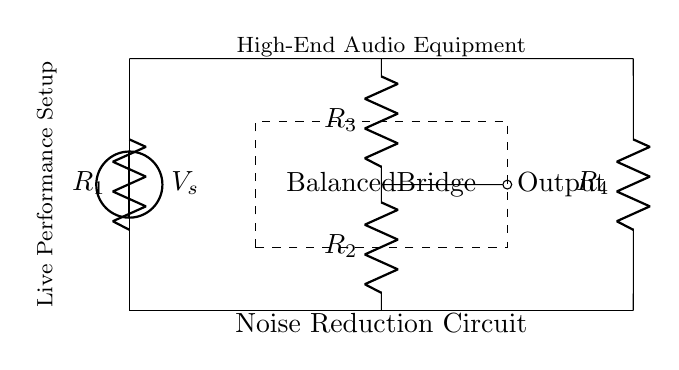What is the total number of resistors in the circuit? There are four resistors labeled R1, R2, R3, and R4 within the circuit, which can be counted directly from the diagram.
Answer: Four What does the rectangle labeled "Balanced Bridge" indicate? The rectangle represents the specific section of the circuit that is designed to balance the voltage and minimize noise. It suggests that the components inside are part of a balanced configuration, crucial for noise reduction in audio applications.
Answer: Noise reduction region What is the purpose of the voltage source in this circuit? The voltage source, denoted as Vs, is placed at the top left corner of the circuit. It provides the necessary potential difference to drive the current through the resistors and allow the circuit to function.
Answer: To provide voltage What is the relationship between R2 and R3 in this circuit? Resistors R2 and R3 are in series with each other according to the connection shown. This implies that the same current flows through both resistors, contributing to the overall voltage drop across them.
Answer: They are in series What output is indicated in the circuit? The circuit shows an output node connected from the junction of R2 and R3, which is critical for measuring the balanced voltage that helps in noise reduction.
Answer: Output from R2 and R3 How does the balance of this bridge affect audio equipment? A balanced bridge configuration reduces the noise that can affect audio signals, providing a cleaner output for high-end audio equipment used in live performances by canceling out differential noise.
Answer: It reduces noise interference What type of configuration does this circuit primarily utilize? The circuit utilizes a balanced bridge configuration, allowing for enhanced stability and noise reduction, which is particularly beneficial in audio signal processing.
Answer: Balanced bridge configuration 